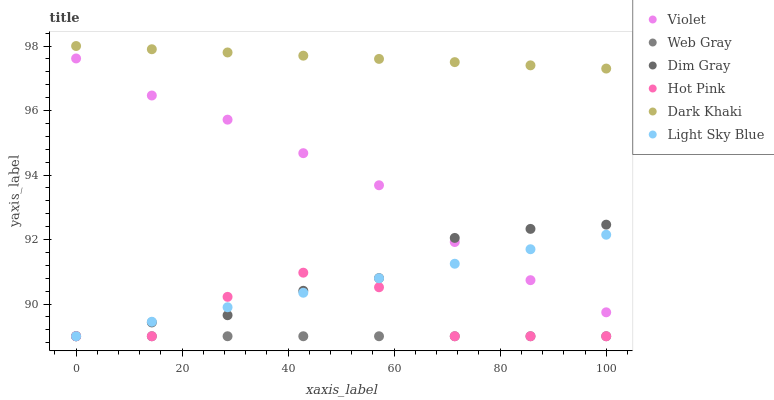Does Web Gray have the minimum area under the curve?
Answer yes or no. Yes. Does Dark Khaki have the maximum area under the curve?
Answer yes or no. Yes. Does Hot Pink have the minimum area under the curve?
Answer yes or no. No. Does Hot Pink have the maximum area under the curve?
Answer yes or no. No. Is Dark Khaki the smoothest?
Answer yes or no. Yes. Is Hot Pink the roughest?
Answer yes or no. Yes. Is Hot Pink the smoothest?
Answer yes or no. No. Is Dark Khaki the roughest?
Answer yes or no. No. Does Dim Gray have the lowest value?
Answer yes or no. Yes. Does Dark Khaki have the lowest value?
Answer yes or no. No. Does Dark Khaki have the highest value?
Answer yes or no. Yes. Does Hot Pink have the highest value?
Answer yes or no. No. Is Light Sky Blue less than Dark Khaki?
Answer yes or no. Yes. Is Violet greater than Hot Pink?
Answer yes or no. Yes. Does Dim Gray intersect Light Sky Blue?
Answer yes or no. Yes. Is Dim Gray less than Light Sky Blue?
Answer yes or no. No. Is Dim Gray greater than Light Sky Blue?
Answer yes or no. No. Does Light Sky Blue intersect Dark Khaki?
Answer yes or no. No. 